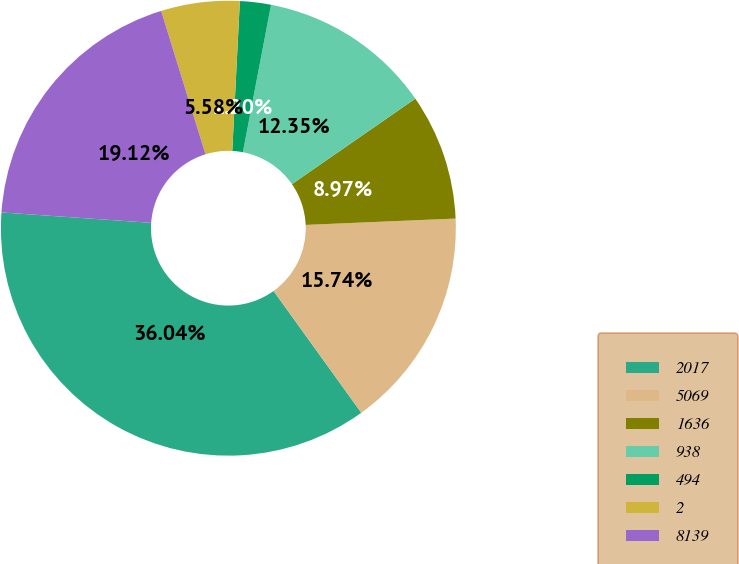Convert chart to OTSL. <chart><loc_0><loc_0><loc_500><loc_500><pie_chart><fcel>2017<fcel>5069<fcel>1636<fcel>938<fcel>494<fcel>2<fcel>8139<nl><fcel>36.04%<fcel>15.74%<fcel>8.97%<fcel>12.35%<fcel>2.2%<fcel>5.58%<fcel>19.12%<nl></chart> 